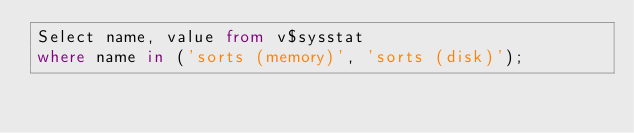<code> <loc_0><loc_0><loc_500><loc_500><_SQL_>Select name, value from v$sysstat
where name in ('sorts (memory)', 'sorts (disk)');</code> 